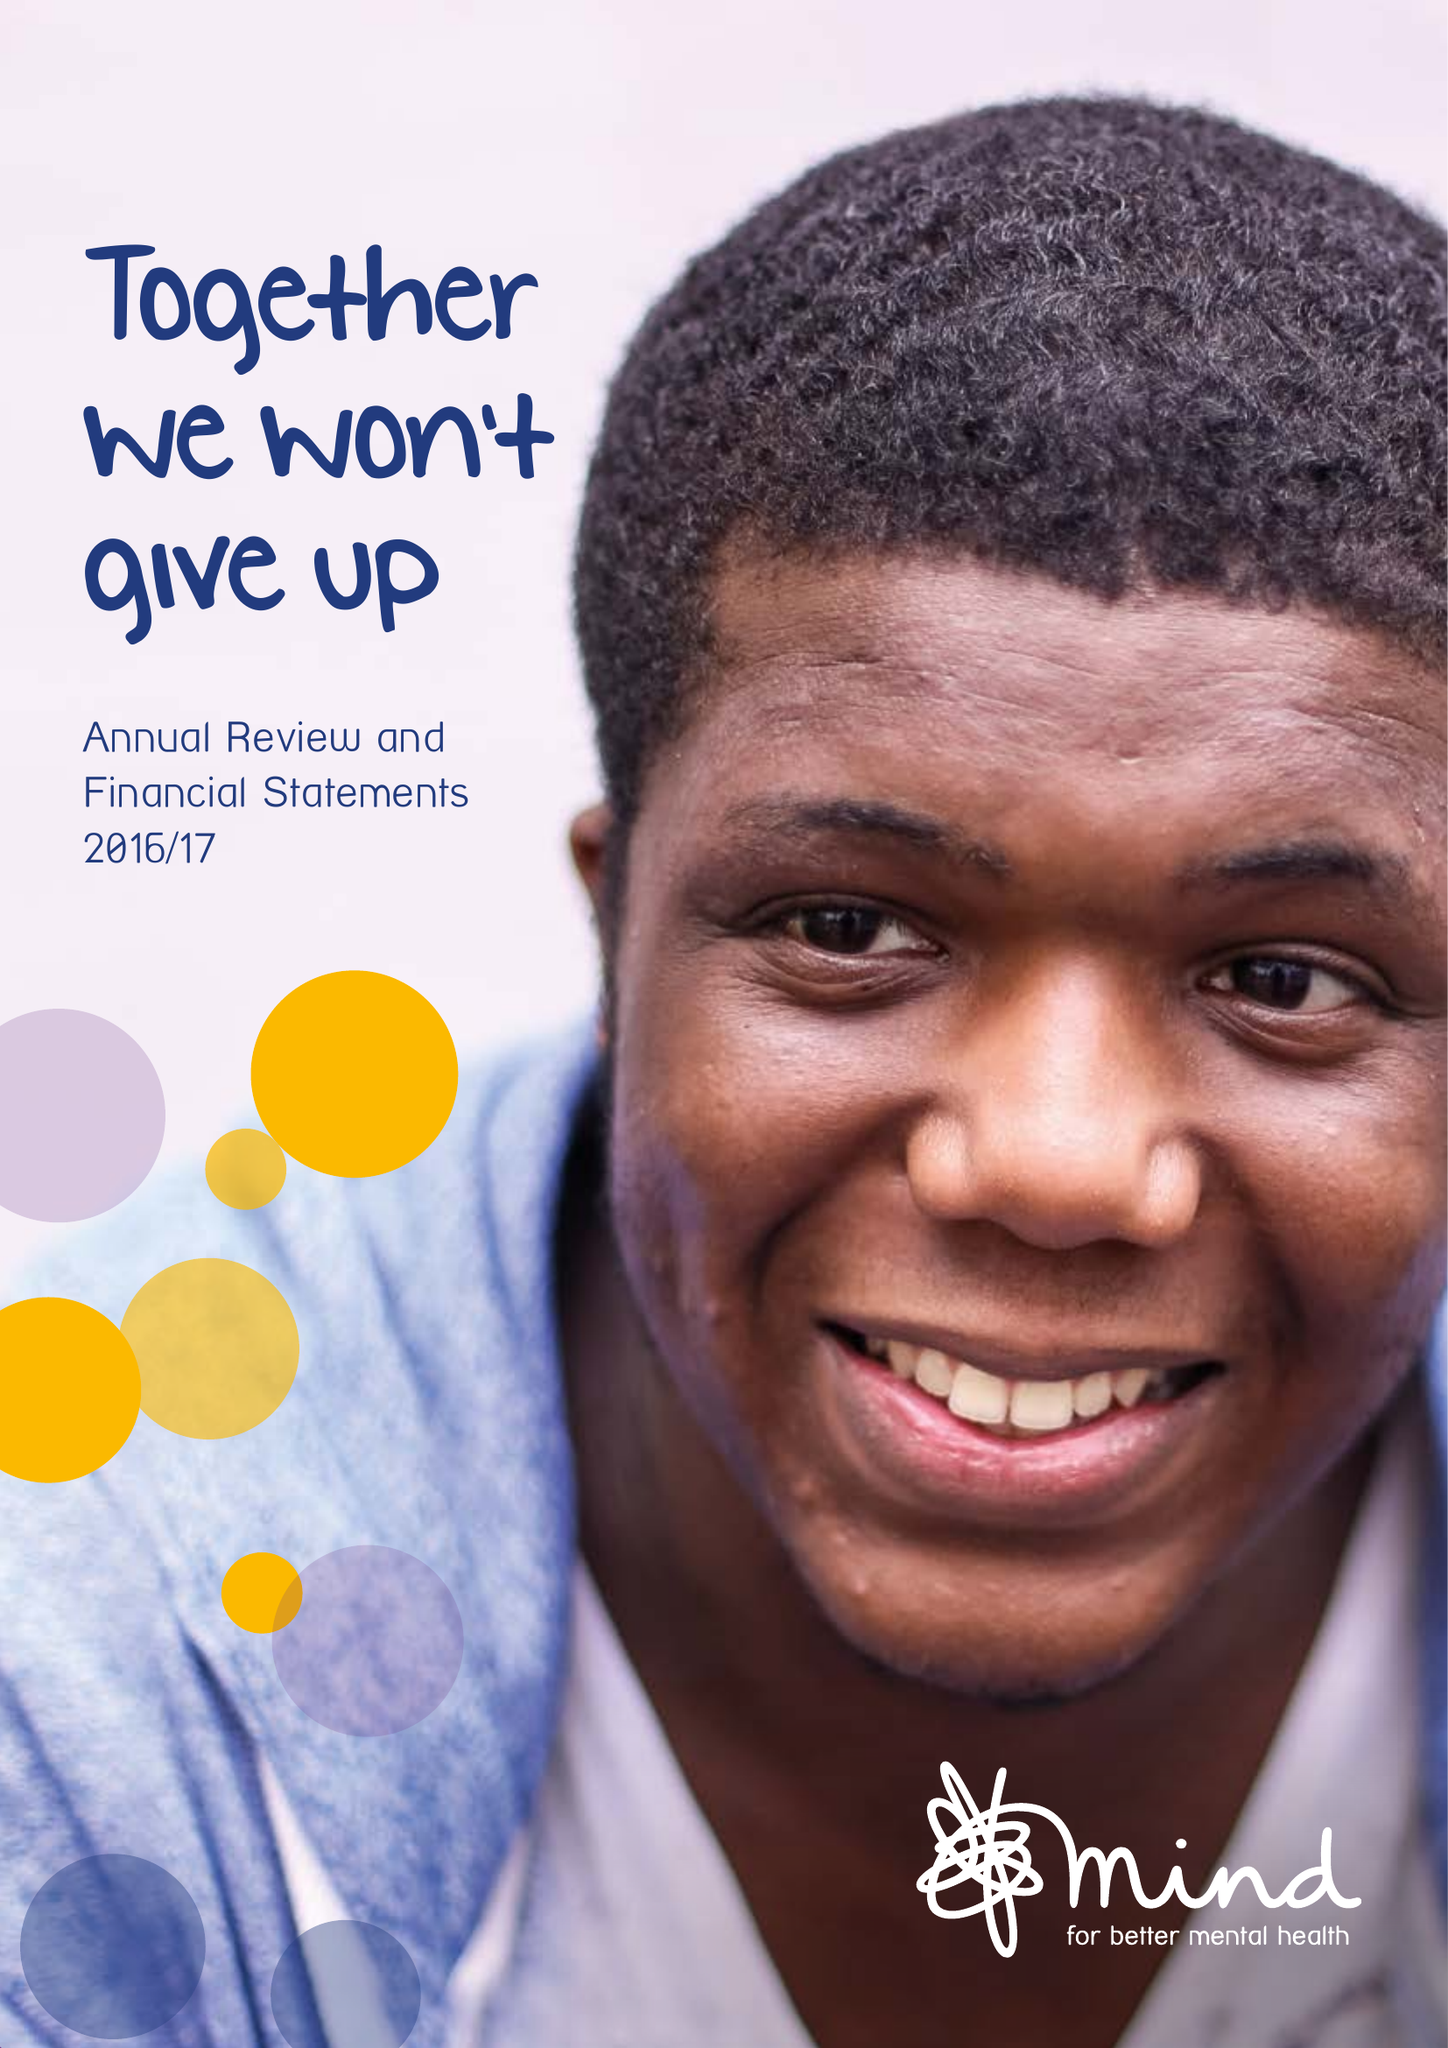What is the value for the address__street_line?
Answer the question using a single word or phrase. 15-19 BROADWAY 